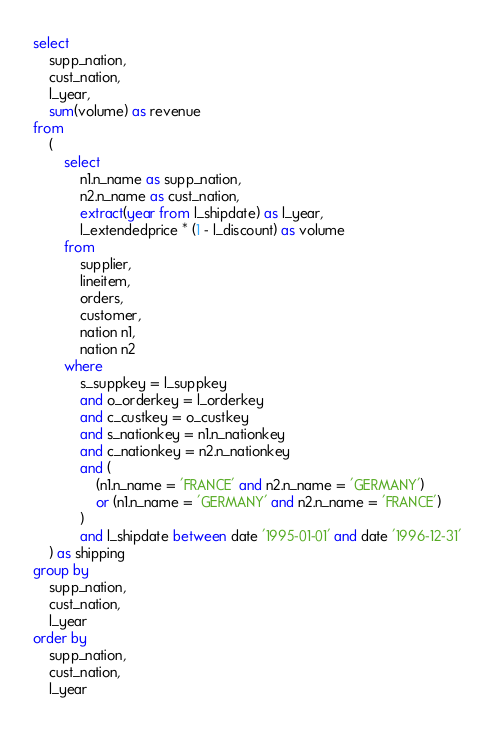Convert code to text. <code><loc_0><loc_0><loc_500><loc_500><_SQL_>select
    supp_nation,
    cust_nation,
    l_year,
    sum(volume) as revenue
from
    (
        select
            n1.n_name as supp_nation,
            n2.n_name as cust_nation,
            extract(year from l_shipdate) as l_year,
            l_extendedprice * (1 - l_discount) as volume
        from
            supplier,
            lineitem,
            orders,
            customer,
            nation n1,
            nation n2
        where
            s_suppkey = l_suppkey
            and o_orderkey = l_orderkey
            and c_custkey = o_custkey
            and s_nationkey = n1.n_nationkey
            and c_nationkey = n2.n_nationkey
            and (
                (n1.n_name = 'FRANCE' and n2.n_name = 'GERMANY')
                or (n1.n_name = 'GERMANY' and n2.n_name = 'FRANCE')
            )
            and l_shipdate between date '1995-01-01' and date '1996-12-31'
    ) as shipping
group by
    supp_nation,
    cust_nation,
    l_year
order by
    supp_nation,
    cust_nation,
    l_year
</code> 